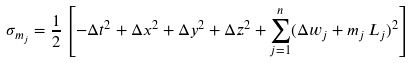Convert formula to latex. <formula><loc_0><loc_0><loc_500><loc_500>\sigma _ { m _ { j } } = \frac { 1 } { 2 } \left [ - \Delta t ^ { 2 } + \Delta x ^ { 2 } + \Delta y ^ { 2 } + \Delta z ^ { 2 } + \sum _ { j = 1 } ^ { n } ( \Delta w _ { j } + m _ { j } \, L _ { j } ) ^ { 2 } \right ]</formula> 